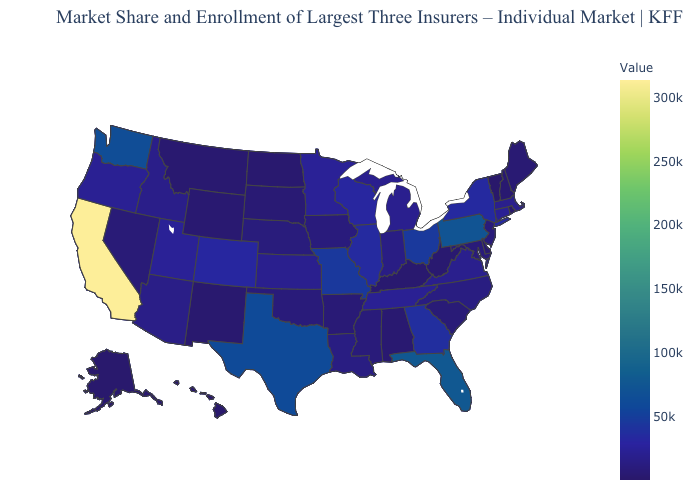Among the states that border Kentucky , which have the highest value?
Be succinct. Ohio. Does Massachusetts have a lower value than Pennsylvania?
Answer briefly. Yes. Which states have the highest value in the USA?
Concise answer only. California. Among the states that border Utah , which have the highest value?
Keep it brief. Colorado. Does Maine have a higher value than Washington?
Keep it brief. No. Among the states that border North Dakota , does Minnesota have the highest value?
Write a very short answer. Yes. Does California have the highest value in the USA?
Quick response, please. Yes. 